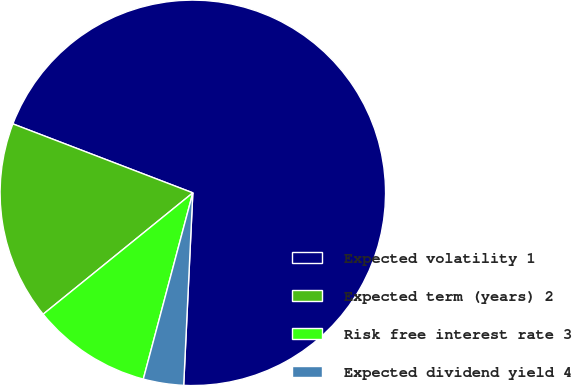Convert chart. <chart><loc_0><loc_0><loc_500><loc_500><pie_chart><fcel>Expected volatility 1<fcel>Expected term (years) 2<fcel>Risk free interest rate 3<fcel>Expected dividend yield 4<nl><fcel>69.93%<fcel>16.67%<fcel>10.02%<fcel>3.38%<nl></chart> 